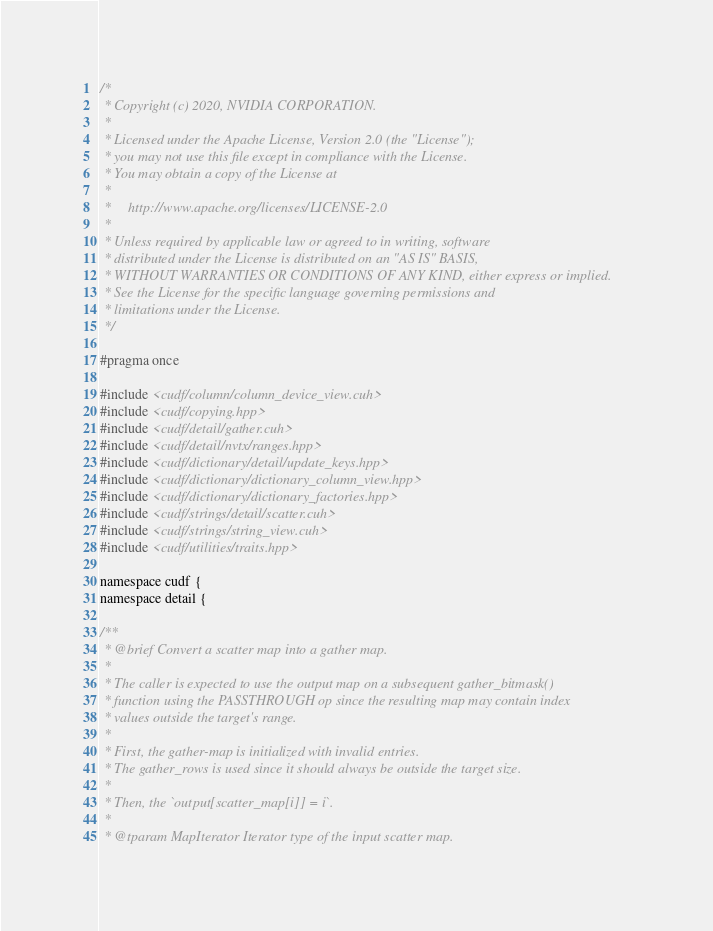<code> <loc_0><loc_0><loc_500><loc_500><_Cuda_>/*
 * Copyright (c) 2020, NVIDIA CORPORATION.
 *
 * Licensed under the Apache License, Version 2.0 (the "License");
 * you may not use this file except in compliance with the License.
 * You may obtain a copy of the License at
 *
 *     http://www.apache.org/licenses/LICENSE-2.0
 *
 * Unless required by applicable law or agreed to in writing, software
 * distributed under the License is distributed on an "AS IS" BASIS,
 * WITHOUT WARRANTIES OR CONDITIONS OF ANY KIND, either express or implied.
 * See the License for the specific language governing permissions and
 * limitations under the License.
 */

#pragma once

#include <cudf/column/column_device_view.cuh>
#include <cudf/copying.hpp>
#include <cudf/detail/gather.cuh>
#include <cudf/detail/nvtx/ranges.hpp>
#include <cudf/dictionary/detail/update_keys.hpp>
#include <cudf/dictionary/dictionary_column_view.hpp>
#include <cudf/dictionary/dictionary_factories.hpp>
#include <cudf/strings/detail/scatter.cuh>
#include <cudf/strings/string_view.cuh>
#include <cudf/utilities/traits.hpp>

namespace cudf {
namespace detail {

/**
 * @brief Convert a scatter map into a gather map.
 *
 * The caller is expected to use the output map on a subsequent gather_bitmask()
 * function using the PASSTHROUGH op since the resulting map may contain index
 * values outside the target's range.
 *
 * First, the gather-map is initialized with invalid entries.
 * The gather_rows is used since it should always be outside the target size.
 *
 * Then, the `output[scatter_map[i]] = i`.
 *
 * @tparam MapIterator Iterator type of the input scatter map.</code> 